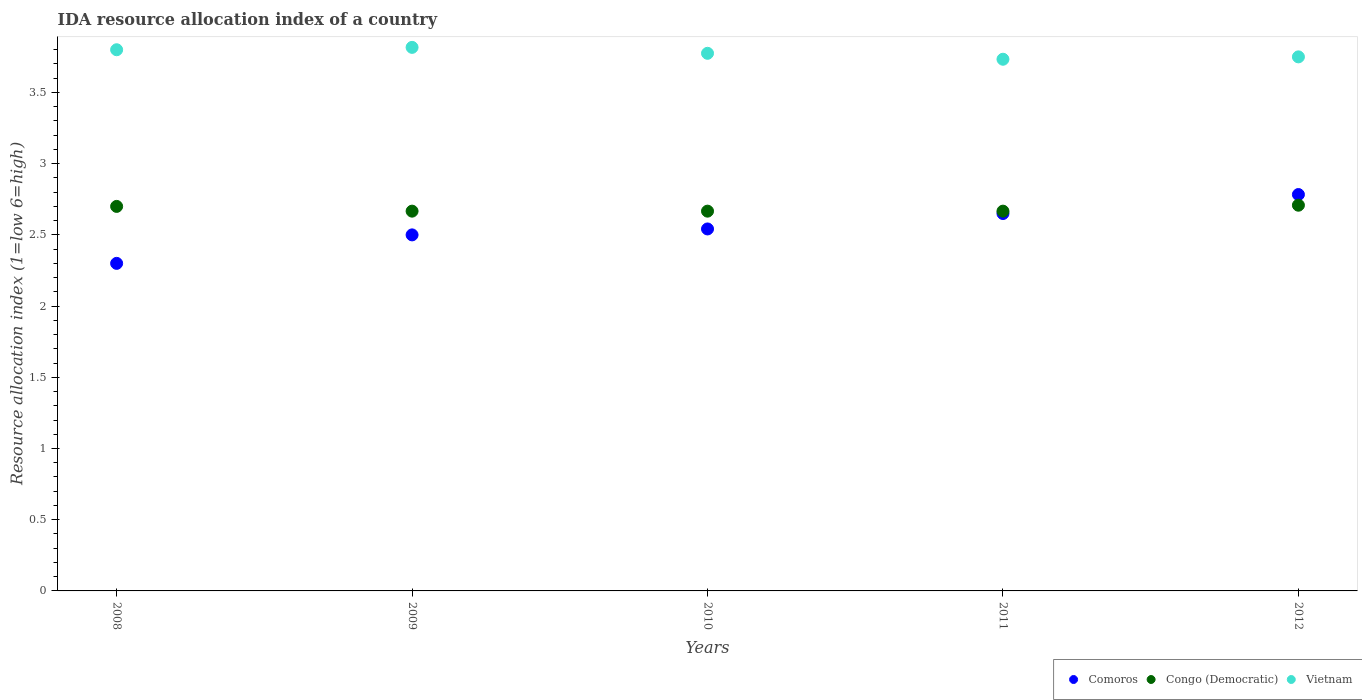What is the IDA resource allocation index in Congo (Democratic) in 2009?
Your response must be concise. 2.67. Across all years, what is the maximum IDA resource allocation index in Vietnam?
Keep it short and to the point. 3.82. Across all years, what is the minimum IDA resource allocation index in Congo (Democratic)?
Offer a terse response. 2.67. In which year was the IDA resource allocation index in Congo (Democratic) maximum?
Make the answer very short. 2012. In which year was the IDA resource allocation index in Vietnam minimum?
Your response must be concise. 2011. What is the total IDA resource allocation index in Vietnam in the graph?
Give a very brief answer. 18.88. What is the difference between the IDA resource allocation index in Comoros in 2009 and that in 2012?
Your answer should be very brief. -0.28. What is the difference between the IDA resource allocation index in Comoros in 2012 and the IDA resource allocation index in Congo (Democratic) in 2010?
Keep it short and to the point. 0.12. What is the average IDA resource allocation index in Congo (Democratic) per year?
Your response must be concise. 2.68. In the year 2009, what is the difference between the IDA resource allocation index in Vietnam and IDA resource allocation index in Comoros?
Your answer should be very brief. 1.32. In how many years, is the IDA resource allocation index in Congo (Democratic) greater than 0.5?
Your answer should be compact. 5. What is the ratio of the IDA resource allocation index in Comoros in 2009 to that in 2010?
Your response must be concise. 0.98. Is the difference between the IDA resource allocation index in Vietnam in 2008 and 2009 greater than the difference between the IDA resource allocation index in Comoros in 2008 and 2009?
Your answer should be compact. Yes. What is the difference between the highest and the second highest IDA resource allocation index in Vietnam?
Your answer should be very brief. 0.02. What is the difference between the highest and the lowest IDA resource allocation index in Vietnam?
Your answer should be compact. 0.08. Is it the case that in every year, the sum of the IDA resource allocation index in Vietnam and IDA resource allocation index in Comoros  is greater than the IDA resource allocation index in Congo (Democratic)?
Your response must be concise. Yes. Is the IDA resource allocation index in Vietnam strictly greater than the IDA resource allocation index in Congo (Democratic) over the years?
Make the answer very short. Yes. How many years are there in the graph?
Your answer should be compact. 5. What is the difference between two consecutive major ticks on the Y-axis?
Ensure brevity in your answer.  0.5. Are the values on the major ticks of Y-axis written in scientific E-notation?
Give a very brief answer. No. How are the legend labels stacked?
Offer a terse response. Horizontal. What is the title of the graph?
Keep it short and to the point. IDA resource allocation index of a country. Does "Georgia" appear as one of the legend labels in the graph?
Ensure brevity in your answer.  No. What is the label or title of the X-axis?
Your answer should be compact. Years. What is the label or title of the Y-axis?
Ensure brevity in your answer.  Resource allocation index (1=low 6=high). What is the Resource allocation index (1=low 6=high) in Comoros in 2008?
Provide a short and direct response. 2.3. What is the Resource allocation index (1=low 6=high) in Congo (Democratic) in 2008?
Provide a succinct answer. 2.7. What is the Resource allocation index (1=low 6=high) of Vietnam in 2008?
Your answer should be compact. 3.8. What is the Resource allocation index (1=low 6=high) of Comoros in 2009?
Provide a short and direct response. 2.5. What is the Resource allocation index (1=low 6=high) of Congo (Democratic) in 2009?
Your answer should be very brief. 2.67. What is the Resource allocation index (1=low 6=high) of Vietnam in 2009?
Your answer should be very brief. 3.82. What is the Resource allocation index (1=low 6=high) of Comoros in 2010?
Your answer should be compact. 2.54. What is the Resource allocation index (1=low 6=high) of Congo (Democratic) in 2010?
Give a very brief answer. 2.67. What is the Resource allocation index (1=low 6=high) of Vietnam in 2010?
Ensure brevity in your answer.  3.77. What is the Resource allocation index (1=low 6=high) in Comoros in 2011?
Offer a terse response. 2.65. What is the Resource allocation index (1=low 6=high) in Congo (Democratic) in 2011?
Ensure brevity in your answer.  2.67. What is the Resource allocation index (1=low 6=high) of Vietnam in 2011?
Give a very brief answer. 3.73. What is the Resource allocation index (1=low 6=high) in Comoros in 2012?
Ensure brevity in your answer.  2.78. What is the Resource allocation index (1=low 6=high) in Congo (Democratic) in 2012?
Offer a terse response. 2.71. What is the Resource allocation index (1=low 6=high) in Vietnam in 2012?
Your response must be concise. 3.75. Across all years, what is the maximum Resource allocation index (1=low 6=high) of Comoros?
Ensure brevity in your answer.  2.78. Across all years, what is the maximum Resource allocation index (1=low 6=high) in Congo (Democratic)?
Offer a very short reply. 2.71. Across all years, what is the maximum Resource allocation index (1=low 6=high) of Vietnam?
Offer a terse response. 3.82. Across all years, what is the minimum Resource allocation index (1=low 6=high) of Congo (Democratic)?
Make the answer very short. 2.67. Across all years, what is the minimum Resource allocation index (1=low 6=high) of Vietnam?
Your response must be concise. 3.73. What is the total Resource allocation index (1=low 6=high) in Comoros in the graph?
Give a very brief answer. 12.78. What is the total Resource allocation index (1=low 6=high) in Congo (Democratic) in the graph?
Offer a very short reply. 13.41. What is the total Resource allocation index (1=low 6=high) of Vietnam in the graph?
Provide a short and direct response. 18.88. What is the difference between the Resource allocation index (1=low 6=high) in Comoros in 2008 and that in 2009?
Your response must be concise. -0.2. What is the difference between the Resource allocation index (1=low 6=high) of Congo (Democratic) in 2008 and that in 2009?
Your answer should be very brief. 0.03. What is the difference between the Resource allocation index (1=low 6=high) in Vietnam in 2008 and that in 2009?
Give a very brief answer. -0.02. What is the difference between the Resource allocation index (1=low 6=high) in Comoros in 2008 and that in 2010?
Offer a terse response. -0.24. What is the difference between the Resource allocation index (1=low 6=high) of Congo (Democratic) in 2008 and that in 2010?
Keep it short and to the point. 0.03. What is the difference between the Resource allocation index (1=low 6=high) in Vietnam in 2008 and that in 2010?
Offer a terse response. 0.03. What is the difference between the Resource allocation index (1=low 6=high) in Comoros in 2008 and that in 2011?
Provide a succinct answer. -0.35. What is the difference between the Resource allocation index (1=low 6=high) of Congo (Democratic) in 2008 and that in 2011?
Offer a terse response. 0.03. What is the difference between the Resource allocation index (1=low 6=high) in Vietnam in 2008 and that in 2011?
Keep it short and to the point. 0.07. What is the difference between the Resource allocation index (1=low 6=high) in Comoros in 2008 and that in 2012?
Give a very brief answer. -0.48. What is the difference between the Resource allocation index (1=low 6=high) of Congo (Democratic) in 2008 and that in 2012?
Provide a succinct answer. -0.01. What is the difference between the Resource allocation index (1=low 6=high) of Vietnam in 2008 and that in 2012?
Offer a very short reply. 0.05. What is the difference between the Resource allocation index (1=low 6=high) in Comoros in 2009 and that in 2010?
Keep it short and to the point. -0.04. What is the difference between the Resource allocation index (1=low 6=high) of Congo (Democratic) in 2009 and that in 2010?
Offer a terse response. 0. What is the difference between the Resource allocation index (1=low 6=high) in Vietnam in 2009 and that in 2010?
Your response must be concise. 0.04. What is the difference between the Resource allocation index (1=low 6=high) in Congo (Democratic) in 2009 and that in 2011?
Keep it short and to the point. 0. What is the difference between the Resource allocation index (1=low 6=high) of Vietnam in 2009 and that in 2011?
Keep it short and to the point. 0.08. What is the difference between the Resource allocation index (1=low 6=high) in Comoros in 2009 and that in 2012?
Make the answer very short. -0.28. What is the difference between the Resource allocation index (1=low 6=high) in Congo (Democratic) in 2009 and that in 2012?
Offer a very short reply. -0.04. What is the difference between the Resource allocation index (1=low 6=high) of Vietnam in 2009 and that in 2012?
Provide a succinct answer. 0.07. What is the difference between the Resource allocation index (1=low 6=high) of Comoros in 2010 and that in 2011?
Offer a very short reply. -0.11. What is the difference between the Resource allocation index (1=low 6=high) in Congo (Democratic) in 2010 and that in 2011?
Your answer should be compact. 0. What is the difference between the Resource allocation index (1=low 6=high) of Vietnam in 2010 and that in 2011?
Offer a very short reply. 0.04. What is the difference between the Resource allocation index (1=low 6=high) of Comoros in 2010 and that in 2012?
Offer a very short reply. -0.24. What is the difference between the Resource allocation index (1=low 6=high) in Congo (Democratic) in 2010 and that in 2012?
Ensure brevity in your answer.  -0.04. What is the difference between the Resource allocation index (1=low 6=high) in Vietnam in 2010 and that in 2012?
Keep it short and to the point. 0.03. What is the difference between the Resource allocation index (1=low 6=high) in Comoros in 2011 and that in 2012?
Offer a very short reply. -0.13. What is the difference between the Resource allocation index (1=low 6=high) of Congo (Democratic) in 2011 and that in 2012?
Offer a very short reply. -0.04. What is the difference between the Resource allocation index (1=low 6=high) in Vietnam in 2011 and that in 2012?
Ensure brevity in your answer.  -0.02. What is the difference between the Resource allocation index (1=low 6=high) in Comoros in 2008 and the Resource allocation index (1=low 6=high) in Congo (Democratic) in 2009?
Offer a terse response. -0.37. What is the difference between the Resource allocation index (1=low 6=high) in Comoros in 2008 and the Resource allocation index (1=low 6=high) in Vietnam in 2009?
Offer a terse response. -1.52. What is the difference between the Resource allocation index (1=low 6=high) of Congo (Democratic) in 2008 and the Resource allocation index (1=low 6=high) of Vietnam in 2009?
Your answer should be compact. -1.12. What is the difference between the Resource allocation index (1=low 6=high) of Comoros in 2008 and the Resource allocation index (1=low 6=high) of Congo (Democratic) in 2010?
Give a very brief answer. -0.37. What is the difference between the Resource allocation index (1=low 6=high) in Comoros in 2008 and the Resource allocation index (1=low 6=high) in Vietnam in 2010?
Your answer should be very brief. -1.48. What is the difference between the Resource allocation index (1=low 6=high) of Congo (Democratic) in 2008 and the Resource allocation index (1=low 6=high) of Vietnam in 2010?
Your answer should be compact. -1.07. What is the difference between the Resource allocation index (1=low 6=high) in Comoros in 2008 and the Resource allocation index (1=low 6=high) in Congo (Democratic) in 2011?
Offer a very short reply. -0.37. What is the difference between the Resource allocation index (1=low 6=high) in Comoros in 2008 and the Resource allocation index (1=low 6=high) in Vietnam in 2011?
Your response must be concise. -1.43. What is the difference between the Resource allocation index (1=low 6=high) of Congo (Democratic) in 2008 and the Resource allocation index (1=low 6=high) of Vietnam in 2011?
Your answer should be very brief. -1.03. What is the difference between the Resource allocation index (1=low 6=high) in Comoros in 2008 and the Resource allocation index (1=low 6=high) in Congo (Democratic) in 2012?
Provide a succinct answer. -0.41. What is the difference between the Resource allocation index (1=low 6=high) of Comoros in 2008 and the Resource allocation index (1=low 6=high) of Vietnam in 2012?
Keep it short and to the point. -1.45. What is the difference between the Resource allocation index (1=low 6=high) of Congo (Democratic) in 2008 and the Resource allocation index (1=low 6=high) of Vietnam in 2012?
Offer a very short reply. -1.05. What is the difference between the Resource allocation index (1=low 6=high) of Comoros in 2009 and the Resource allocation index (1=low 6=high) of Vietnam in 2010?
Your response must be concise. -1.27. What is the difference between the Resource allocation index (1=low 6=high) of Congo (Democratic) in 2009 and the Resource allocation index (1=low 6=high) of Vietnam in 2010?
Provide a succinct answer. -1.11. What is the difference between the Resource allocation index (1=low 6=high) of Comoros in 2009 and the Resource allocation index (1=low 6=high) of Congo (Democratic) in 2011?
Give a very brief answer. -0.17. What is the difference between the Resource allocation index (1=low 6=high) of Comoros in 2009 and the Resource allocation index (1=low 6=high) of Vietnam in 2011?
Make the answer very short. -1.23. What is the difference between the Resource allocation index (1=low 6=high) of Congo (Democratic) in 2009 and the Resource allocation index (1=low 6=high) of Vietnam in 2011?
Your answer should be very brief. -1.07. What is the difference between the Resource allocation index (1=low 6=high) in Comoros in 2009 and the Resource allocation index (1=low 6=high) in Congo (Democratic) in 2012?
Ensure brevity in your answer.  -0.21. What is the difference between the Resource allocation index (1=low 6=high) of Comoros in 2009 and the Resource allocation index (1=low 6=high) of Vietnam in 2012?
Ensure brevity in your answer.  -1.25. What is the difference between the Resource allocation index (1=low 6=high) in Congo (Democratic) in 2009 and the Resource allocation index (1=low 6=high) in Vietnam in 2012?
Offer a very short reply. -1.08. What is the difference between the Resource allocation index (1=low 6=high) in Comoros in 2010 and the Resource allocation index (1=low 6=high) in Congo (Democratic) in 2011?
Provide a short and direct response. -0.12. What is the difference between the Resource allocation index (1=low 6=high) of Comoros in 2010 and the Resource allocation index (1=low 6=high) of Vietnam in 2011?
Offer a terse response. -1.19. What is the difference between the Resource allocation index (1=low 6=high) in Congo (Democratic) in 2010 and the Resource allocation index (1=low 6=high) in Vietnam in 2011?
Keep it short and to the point. -1.07. What is the difference between the Resource allocation index (1=low 6=high) of Comoros in 2010 and the Resource allocation index (1=low 6=high) of Vietnam in 2012?
Ensure brevity in your answer.  -1.21. What is the difference between the Resource allocation index (1=low 6=high) of Congo (Democratic) in 2010 and the Resource allocation index (1=low 6=high) of Vietnam in 2012?
Provide a succinct answer. -1.08. What is the difference between the Resource allocation index (1=low 6=high) of Comoros in 2011 and the Resource allocation index (1=low 6=high) of Congo (Democratic) in 2012?
Ensure brevity in your answer.  -0.06. What is the difference between the Resource allocation index (1=low 6=high) in Congo (Democratic) in 2011 and the Resource allocation index (1=low 6=high) in Vietnam in 2012?
Offer a terse response. -1.08. What is the average Resource allocation index (1=low 6=high) in Comoros per year?
Offer a very short reply. 2.56. What is the average Resource allocation index (1=low 6=high) in Congo (Democratic) per year?
Your response must be concise. 2.68. What is the average Resource allocation index (1=low 6=high) in Vietnam per year?
Ensure brevity in your answer.  3.77. In the year 2008, what is the difference between the Resource allocation index (1=low 6=high) of Congo (Democratic) and Resource allocation index (1=low 6=high) of Vietnam?
Provide a succinct answer. -1.1. In the year 2009, what is the difference between the Resource allocation index (1=low 6=high) of Comoros and Resource allocation index (1=low 6=high) of Congo (Democratic)?
Your response must be concise. -0.17. In the year 2009, what is the difference between the Resource allocation index (1=low 6=high) in Comoros and Resource allocation index (1=low 6=high) in Vietnam?
Your response must be concise. -1.32. In the year 2009, what is the difference between the Resource allocation index (1=low 6=high) in Congo (Democratic) and Resource allocation index (1=low 6=high) in Vietnam?
Offer a very short reply. -1.15. In the year 2010, what is the difference between the Resource allocation index (1=low 6=high) of Comoros and Resource allocation index (1=low 6=high) of Congo (Democratic)?
Provide a succinct answer. -0.12. In the year 2010, what is the difference between the Resource allocation index (1=low 6=high) in Comoros and Resource allocation index (1=low 6=high) in Vietnam?
Make the answer very short. -1.23. In the year 2010, what is the difference between the Resource allocation index (1=low 6=high) in Congo (Democratic) and Resource allocation index (1=low 6=high) in Vietnam?
Make the answer very short. -1.11. In the year 2011, what is the difference between the Resource allocation index (1=low 6=high) of Comoros and Resource allocation index (1=low 6=high) of Congo (Democratic)?
Offer a very short reply. -0.02. In the year 2011, what is the difference between the Resource allocation index (1=low 6=high) of Comoros and Resource allocation index (1=low 6=high) of Vietnam?
Offer a terse response. -1.08. In the year 2011, what is the difference between the Resource allocation index (1=low 6=high) of Congo (Democratic) and Resource allocation index (1=low 6=high) of Vietnam?
Your response must be concise. -1.07. In the year 2012, what is the difference between the Resource allocation index (1=low 6=high) of Comoros and Resource allocation index (1=low 6=high) of Congo (Democratic)?
Ensure brevity in your answer.  0.07. In the year 2012, what is the difference between the Resource allocation index (1=low 6=high) in Comoros and Resource allocation index (1=low 6=high) in Vietnam?
Provide a short and direct response. -0.97. In the year 2012, what is the difference between the Resource allocation index (1=low 6=high) of Congo (Democratic) and Resource allocation index (1=low 6=high) of Vietnam?
Your answer should be very brief. -1.04. What is the ratio of the Resource allocation index (1=low 6=high) of Congo (Democratic) in 2008 to that in 2009?
Give a very brief answer. 1.01. What is the ratio of the Resource allocation index (1=low 6=high) in Comoros in 2008 to that in 2010?
Offer a very short reply. 0.9. What is the ratio of the Resource allocation index (1=low 6=high) in Congo (Democratic) in 2008 to that in 2010?
Provide a succinct answer. 1.01. What is the ratio of the Resource allocation index (1=low 6=high) of Vietnam in 2008 to that in 2010?
Keep it short and to the point. 1.01. What is the ratio of the Resource allocation index (1=low 6=high) of Comoros in 2008 to that in 2011?
Give a very brief answer. 0.87. What is the ratio of the Resource allocation index (1=low 6=high) in Congo (Democratic) in 2008 to that in 2011?
Provide a short and direct response. 1.01. What is the ratio of the Resource allocation index (1=low 6=high) of Vietnam in 2008 to that in 2011?
Make the answer very short. 1.02. What is the ratio of the Resource allocation index (1=low 6=high) of Comoros in 2008 to that in 2012?
Provide a short and direct response. 0.83. What is the ratio of the Resource allocation index (1=low 6=high) of Vietnam in 2008 to that in 2012?
Provide a succinct answer. 1.01. What is the ratio of the Resource allocation index (1=low 6=high) of Comoros in 2009 to that in 2010?
Your response must be concise. 0.98. What is the ratio of the Resource allocation index (1=low 6=high) of Vietnam in 2009 to that in 2010?
Offer a very short reply. 1.01. What is the ratio of the Resource allocation index (1=low 6=high) in Comoros in 2009 to that in 2011?
Offer a very short reply. 0.94. What is the ratio of the Resource allocation index (1=low 6=high) of Congo (Democratic) in 2009 to that in 2011?
Make the answer very short. 1. What is the ratio of the Resource allocation index (1=low 6=high) in Vietnam in 2009 to that in 2011?
Your answer should be compact. 1.02. What is the ratio of the Resource allocation index (1=low 6=high) of Comoros in 2009 to that in 2012?
Provide a succinct answer. 0.9. What is the ratio of the Resource allocation index (1=low 6=high) of Congo (Democratic) in 2009 to that in 2012?
Provide a succinct answer. 0.98. What is the ratio of the Resource allocation index (1=low 6=high) of Vietnam in 2009 to that in 2012?
Provide a short and direct response. 1.02. What is the ratio of the Resource allocation index (1=low 6=high) of Comoros in 2010 to that in 2011?
Give a very brief answer. 0.96. What is the ratio of the Resource allocation index (1=low 6=high) in Congo (Democratic) in 2010 to that in 2011?
Offer a terse response. 1. What is the ratio of the Resource allocation index (1=low 6=high) in Vietnam in 2010 to that in 2011?
Provide a short and direct response. 1.01. What is the ratio of the Resource allocation index (1=low 6=high) in Comoros in 2010 to that in 2012?
Provide a short and direct response. 0.91. What is the ratio of the Resource allocation index (1=low 6=high) in Congo (Democratic) in 2010 to that in 2012?
Provide a short and direct response. 0.98. What is the ratio of the Resource allocation index (1=low 6=high) in Comoros in 2011 to that in 2012?
Your answer should be very brief. 0.95. What is the ratio of the Resource allocation index (1=low 6=high) of Congo (Democratic) in 2011 to that in 2012?
Keep it short and to the point. 0.98. What is the difference between the highest and the second highest Resource allocation index (1=low 6=high) in Comoros?
Keep it short and to the point. 0.13. What is the difference between the highest and the second highest Resource allocation index (1=low 6=high) of Congo (Democratic)?
Your response must be concise. 0.01. What is the difference between the highest and the second highest Resource allocation index (1=low 6=high) in Vietnam?
Your response must be concise. 0.02. What is the difference between the highest and the lowest Resource allocation index (1=low 6=high) of Comoros?
Give a very brief answer. 0.48. What is the difference between the highest and the lowest Resource allocation index (1=low 6=high) in Congo (Democratic)?
Your answer should be compact. 0.04. What is the difference between the highest and the lowest Resource allocation index (1=low 6=high) in Vietnam?
Keep it short and to the point. 0.08. 